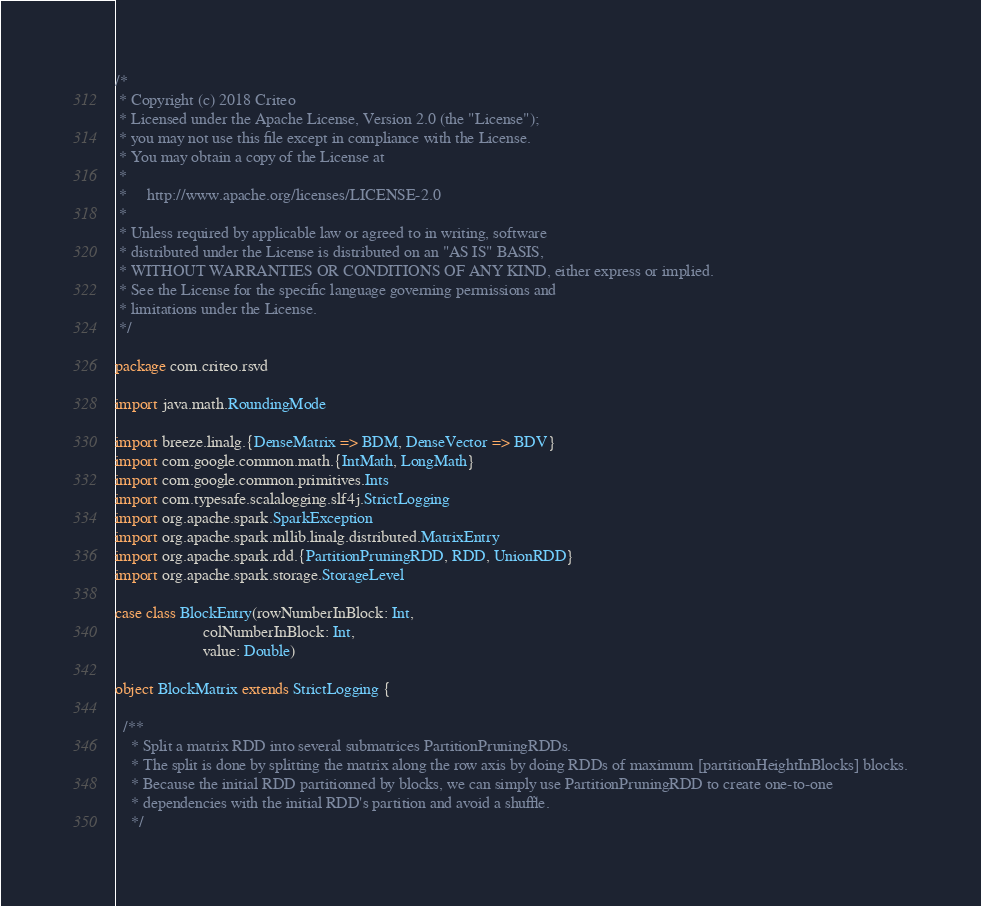Convert code to text. <code><loc_0><loc_0><loc_500><loc_500><_Scala_>/*
 * Copyright (c) 2018 Criteo
 * Licensed under the Apache License, Version 2.0 (the "License");
 * you may not use this file except in compliance with the License.
 * You may obtain a copy of the License at
 *
 *     http://www.apache.org/licenses/LICENSE-2.0
 *
 * Unless required by applicable law or agreed to in writing, software
 * distributed under the License is distributed on an "AS IS" BASIS,
 * WITHOUT WARRANTIES OR CONDITIONS OF ANY KIND, either express or implied.
 * See the License for the specific language governing permissions and
 * limitations under the License.
 */

package com.criteo.rsvd

import java.math.RoundingMode

import breeze.linalg.{DenseMatrix => BDM, DenseVector => BDV}
import com.google.common.math.{IntMath, LongMath}
import com.google.common.primitives.Ints
import com.typesafe.scalalogging.slf4j.StrictLogging
import org.apache.spark.SparkException
import org.apache.spark.mllib.linalg.distributed.MatrixEntry
import org.apache.spark.rdd.{PartitionPruningRDD, RDD, UnionRDD}
import org.apache.spark.storage.StorageLevel

case class BlockEntry(rowNumberInBlock: Int,
                      colNumberInBlock: Int,
                      value: Double)

object BlockMatrix extends StrictLogging {

  /**
    * Split a matrix RDD into several submatrices PartitionPruningRDDs.
    * The split is done by splitting the matrix along the row axis by doing RDDs of maximum [partitionHeightInBlocks] blocks.
    * Because the initial RDD partitionned by blocks, we can simply use PartitionPruningRDD to create one-to-one
    * dependencies with the initial RDD's partition and avoid a shuffle.
    */</code> 